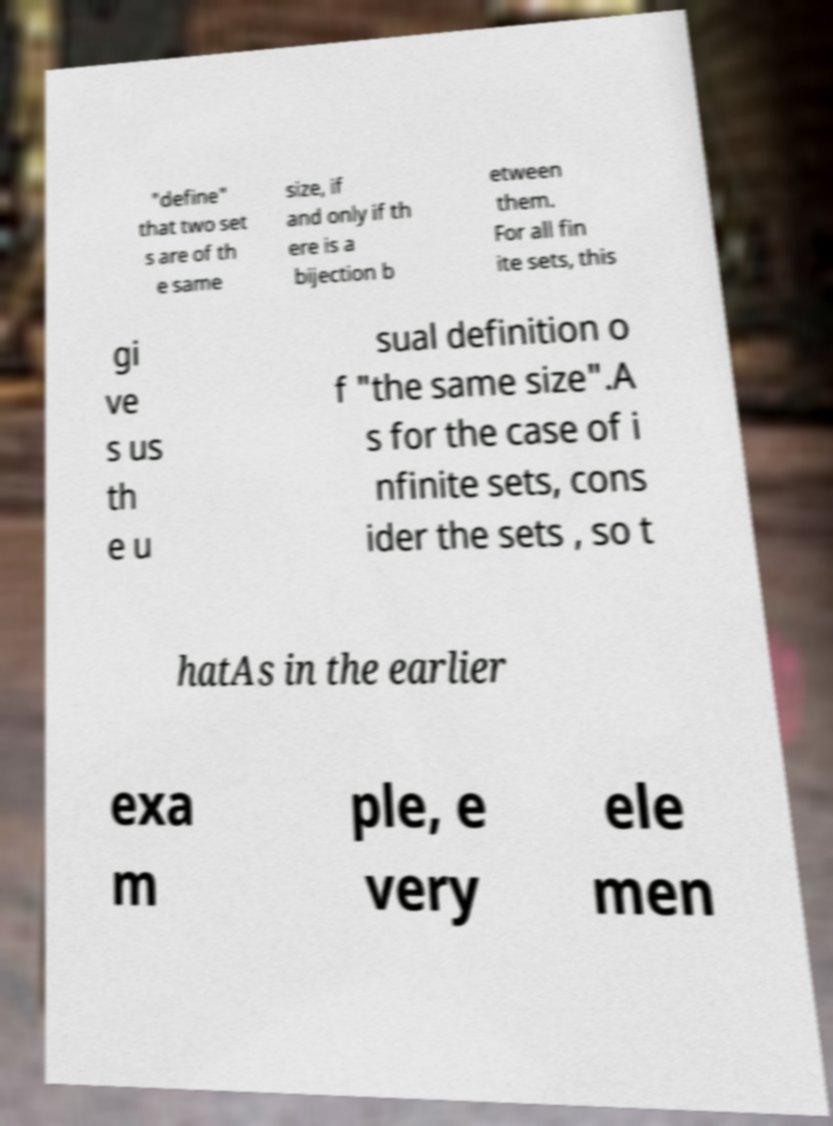I need the written content from this picture converted into text. Can you do that? "define" that two set s are of th e same size, if and only if th ere is a bijection b etween them. For all fin ite sets, this gi ve s us th e u sual definition o f "the same size".A s for the case of i nfinite sets, cons ider the sets , so t hatAs in the earlier exa m ple, e very ele men 